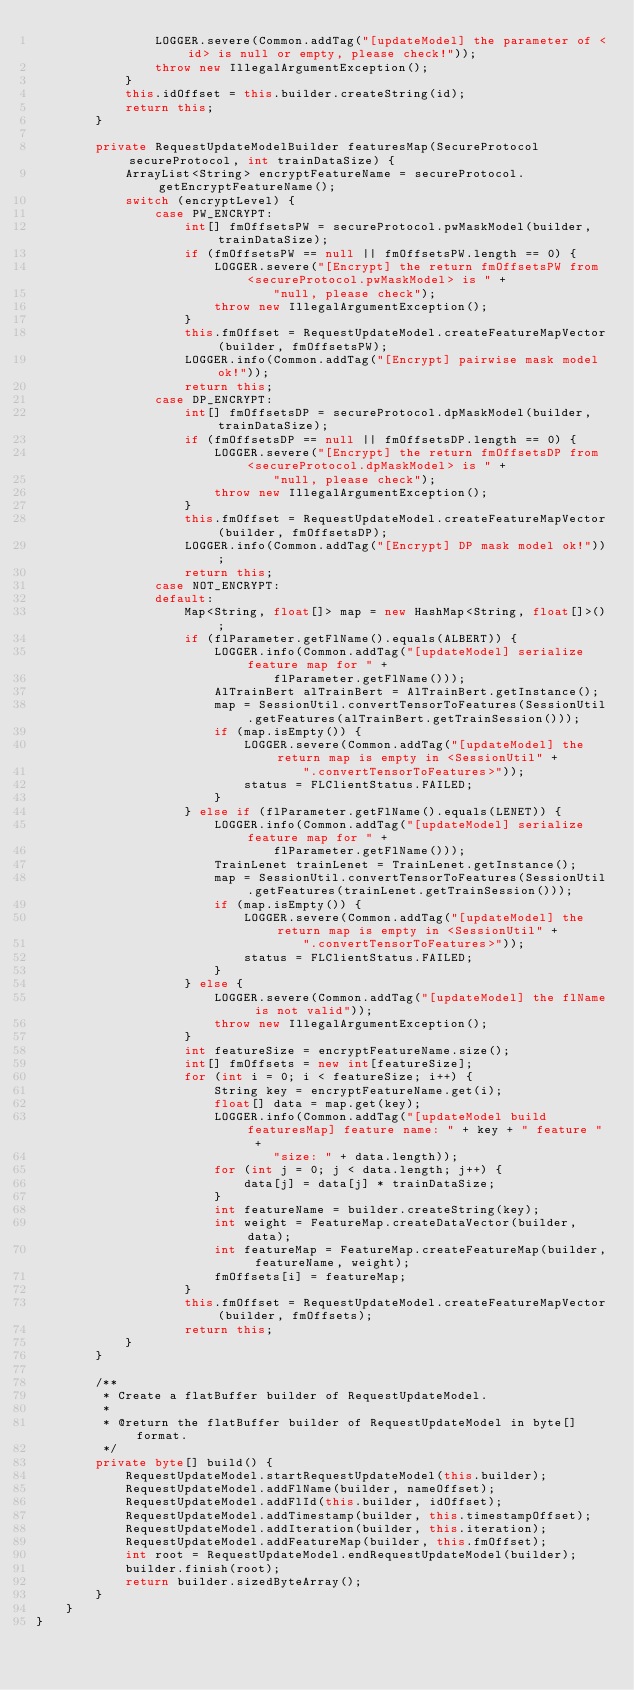<code> <loc_0><loc_0><loc_500><loc_500><_Java_>                LOGGER.severe(Common.addTag("[updateModel] the parameter of <id> is null or empty, please check!"));
                throw new IllegalArgumentException();
            }
            this.idOffset = this.builder.createString(id);
            return this;
        }

        private RequestUpdateModelBuilder featuresMap(SecureProtocol secureProtocol, int trainDataSize) {
            ArrayList<String> encryptFeatureName = secureProtocol.getEncryptFeatureName();
            switch (encryptLevel) {
                case PW_ENCRYPT:
                    int[] fmOffsetsPW = secureProtocol.pwMaskModel(builder, trainDataSize);
                    if (fmOffsetsPW == null || fmOffsetsPW.length == 0) {
                        LOGGER.severe("[Encrypt] the return fmOffsetsPW from <secureProtocol.pwMaskModel> is " +
                                "null, please check");
                        throw new IllegalArgumentException();
                    }
                    this.fmOffset = RequestUpdateModel.createFeatureMapVector(builder, fmOffsetsPW);
                    LOGGER.info(Common.addTag("[Encrypt] pairwise mask model ok!"));
                    return this;
                case DP_ENCRYPT:
                    int[] fmOffsetsDP = secureProtocol.dpMaskModel(builder, trainDataSize);
                    if (fmOffsetsDP == null || fmOffsetsDP.length == 0) {
                        LOGGER.severe("[Encrypt] the return fmOffsetsDP from <secureProtocol.dpMaskModel> is " +
                                "null, please check");
                        throw new IllegalArgumentException();
                    }
                    this.fmOffset = RequestUpdateModel.createFeatureMapVector(builder, fmOffsetsDP);
                    LOGGER.info(Common.addTag("[Encrypt] DP mask model ok!"));
                    return this;
                case NOT_ENCRYPT:
                default:
                    Map<String, float[]> map = new HashMap<String, float[]>();
                    if (flParameter.getFlName().equals(ALBERT)) {
                        LOGGER.info(Common.addTag("[updateModel] serialize feature map for " +
                                flParameter.getFlName()));
                        AlTrainBert alTrainBert = AlTrainBert.getInstance();
                        map = SessionUtil.convertTensorToFeatures(SessionUtil.getFeatures(alTrainBert.getTrainSession()));
                        if (map.isEmpty()) {
                            LOGGER.severe(Common.addTag("[updateModel] the return map is empty in <SessionUtil" +
                                    ".convertTensorToFeatures>"));
                            status = FLClientStatus.FAILED;
                        }
                    } else if (flParameter.getFlName().equals(LENET)) {
                        LOGGER.info(Common.addTag("[updateModel] serialize feature map for " +
                                flParameter.getFlName()));
                        TrainLenet trainLenet = TrainLenet.getInstance();
                        map = SessionUtil.convertTensorToFeatures(SessionUtil.getFeatures(trainLenet.getTrainSession()));
                        if (map.isEmpty()) {
                            LOGGER.severe(Common.addTag("[updateModel] the return map is empty in <SessionUtil" +
                                    ".convertTensorToFeatures>"));
                            status = FLClientStatus.FAILED;
                        }
                    } else {
                        LOGGER.severe(Common.addTag("[updateModel] the flName is not valid"));
                        throw new IllegalArgumentException();
                    }
                    int featureSize = encryptFeatureName.size();
                    int[] fmOffsets = new int[featureSize];
                    for (int i = 0; i < featureSize; i++) {
                        String key = encryptFeatureName.get(i);
                        float[] data = map.get(key);
                        LOGGER.info(Common.addTag("[updateModel build featuresMap] feature name: " + key + " feature " +
                                "size: " + data.length));
                        for (int j = 0; j < data.length; j++) {
                            data[j] = data[j] * trainDataSize;
                        }
                        int featureName = builder.createString(key);
                        int weight = FeatureMap.createDataVector(builder, data);
                        int featureMap = FeatureMap.createFeatureMap(builder, featureName, weight);
                        fmOffsets[i] = featureMap;
                    }
                    this.fmOffset = RequestUpdateModel.createFeatureMapVector(builder, fmOffsets);
                    return this;
            }
        }

        /**
         * Create a flatBuffer builder of RequestUpdateModel.
         *
         * @return the flatBuffer builder of RequestUpdateModel in byte[] format.
         */
        private byte[] build() {
            RequestUpdateModel.startRequestUpdateModel(this.builder);
            RequestUpdateModel.addFlName(builder, nameOffset);
            RequestUpdateModel.addFlId(this.builder, idOffset);
            RequestUpdateModel.addTimestamp(builder, this.timestampOffset);
            RequestUpdateModel.addIteration(builder, this.iteration);
            RequestUpdateModel.addFeatureMap(builder, this.fmOffset);
            int root = RequestUpdateModel.endRequestUpdateModel(builder);
            builder.finish(root);
            return builder.sizedByteArray();
        }
    }
}
</code> 